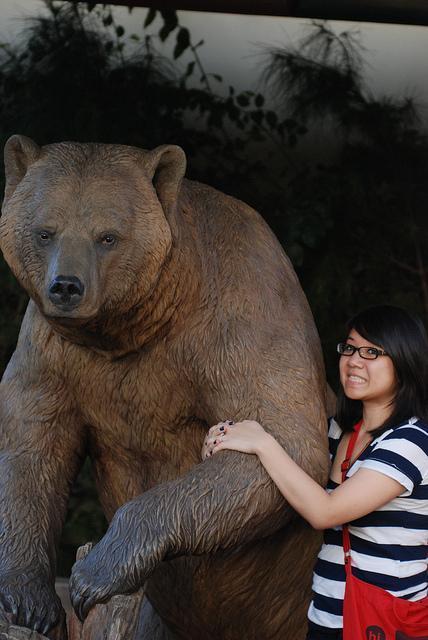How many people in this photo?
Give a very brief answer. 1. How many animals are there in this picture?
Give a very brief answer. 1. How many bears are there?
Give a very brief answer. 1. How many umbrellas do you see?
Give a very brief answer. 0. 